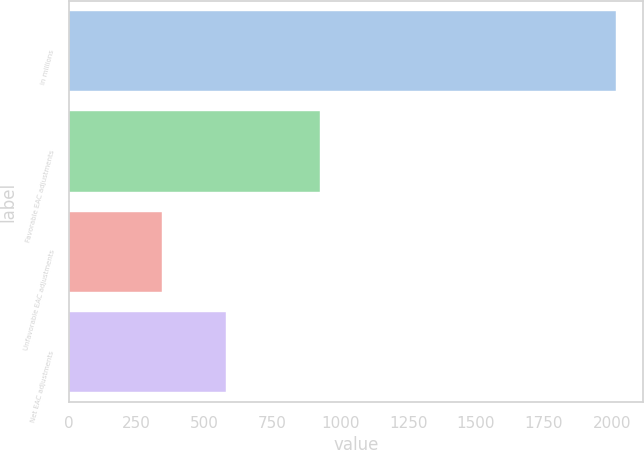Convert chart to OTSL. <chart><loc_0><loc_0><loc_500><loc_500><bar_chart><fcel>in millions<fcel>Favorable EAC adjustments<fcel>Unfavorable EAC adjustments<fcel>Net EAC adjustments<nl><fcel>2015<fcel>924<fcel>344<fcel>580<nl></chart> 